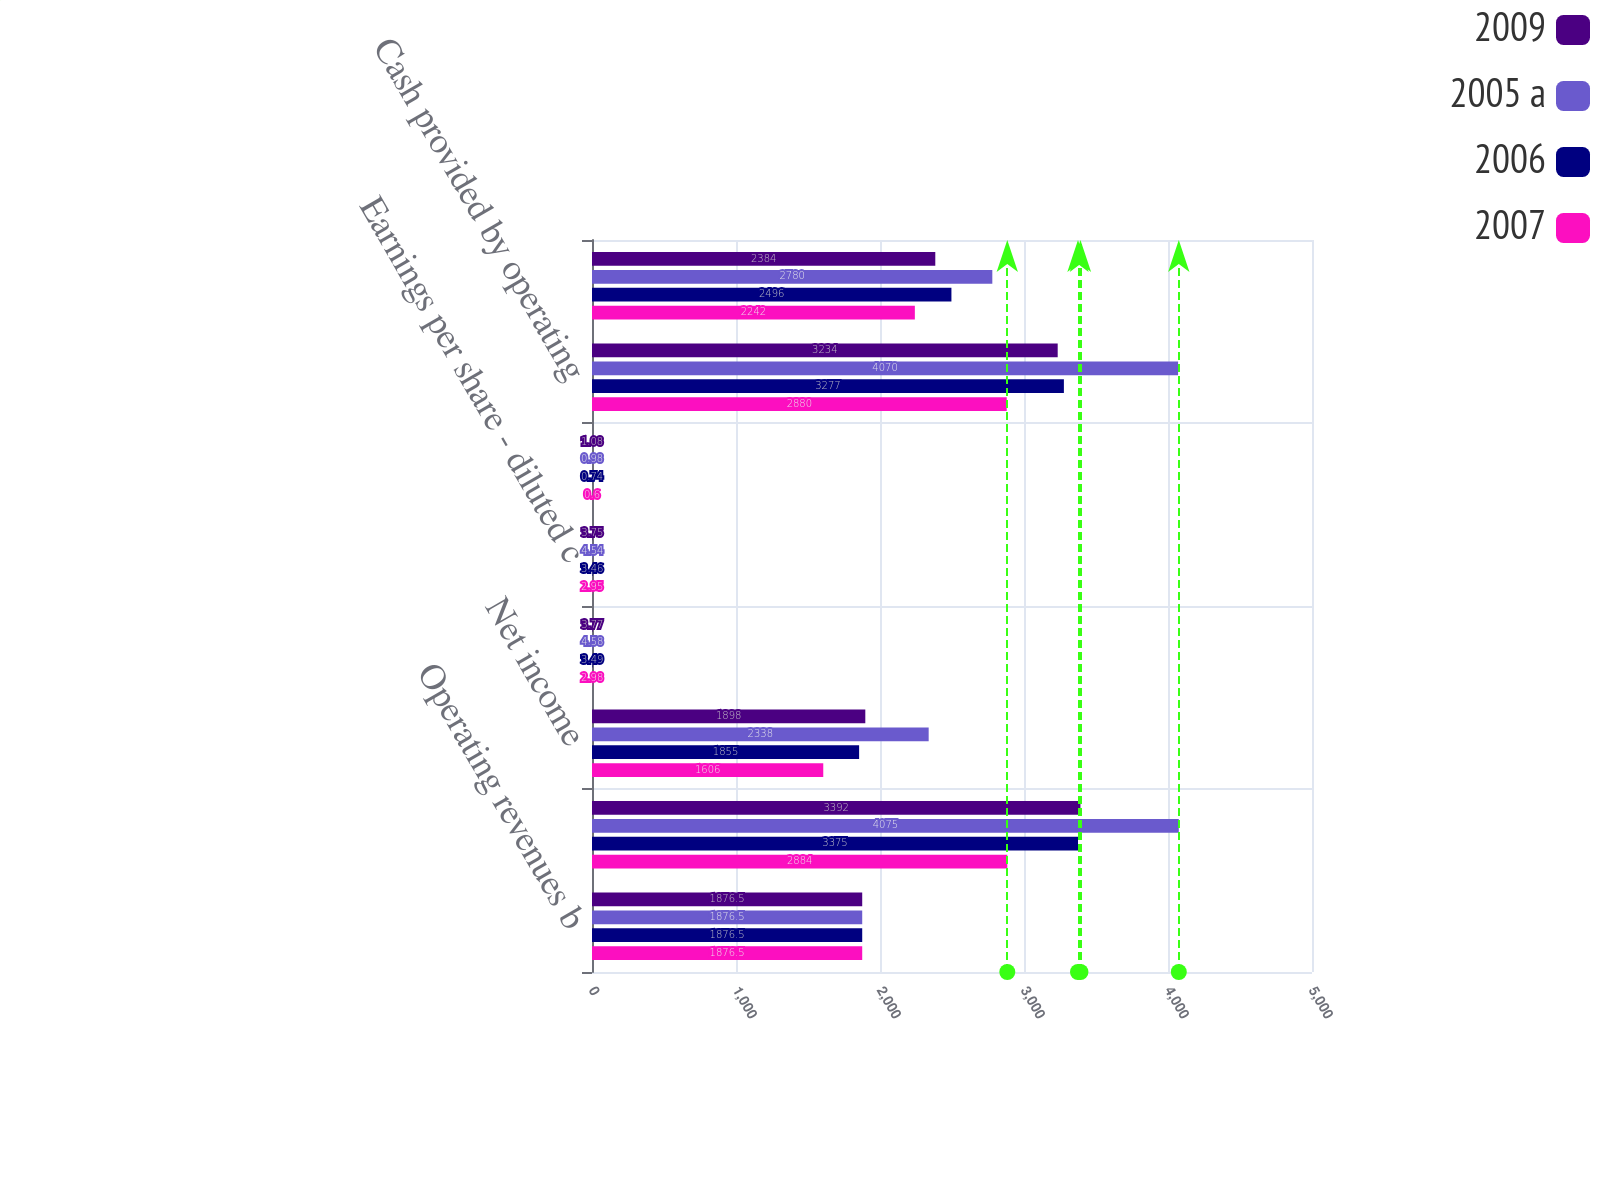Convert chart. <chart><loc_0><loc_0><loc_500><loc_500><stacked_bar_chart><ecel><fcel>Operating revenues b<fcel>Operating income<fcel>Net income<fcel>Earnings per share - basic c<fcel>Earnings per share - diluted c<fcel>Dividends declared per share c<fcel>Cash provided by operating<fcel>Cash used for capital<nl><fcel>2009<fcel>1876.5<fcel>3392<fcel>1898<fcel>3.77<fcel>3.75<fcel>1.08<fcel>3234<fcel>2384<nl><fcel>2005 a<fcel>1876.5<fcel>4075<fcel>2338<fcel>4.58<fcel>4.54<fcel>0.98<fcel>4070<fcel>2780<nl><fcel>2006<fcel>1876.5<fcel>3375<fcel>1855<fcel>3.49<fcel>3.46<fcel>0.74<fcel>3277<fcel>2496<nl><fcel>2007<fcel>1876.5<fcel>2884<fcel>1606<fcel>2.98<fcel>2.95<fcel>0.6<fcel>2880<fcel>2242<nl></chart> 